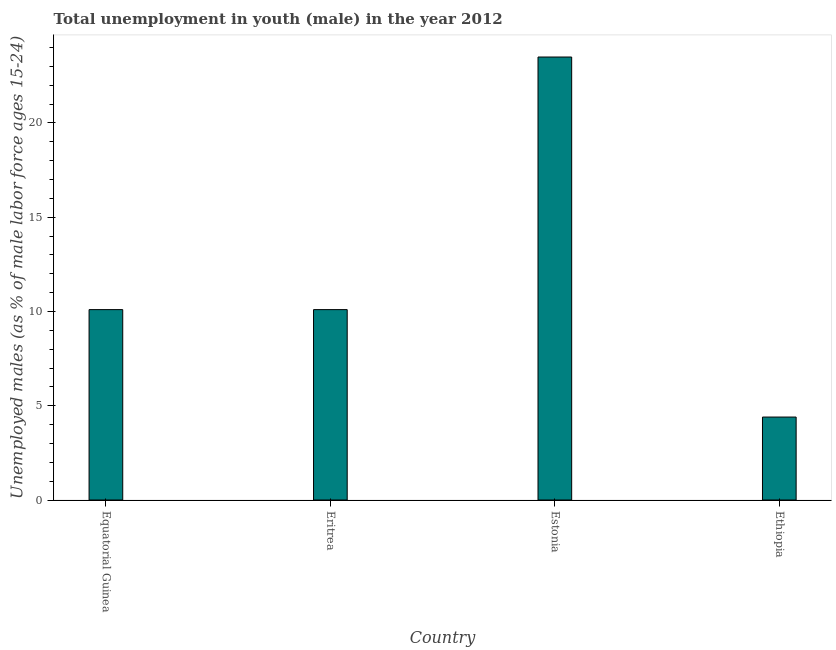Does the graph contain any zero values?
Give a very brief answer. No. Does the graph contain grids?
Offer a terse response. No. What is the title of the graph?
Offer a terse response. Total unemployment in youth (male) in the year 2012. What is the label or title of the Y-axis?
Ensure brevity in your answer.  Unemployed males (as % of male labor force ages 15-24). What is the unemployed male youth population in Equatorial Guinea?
Provide a succinct answer. 10.1. Across all countries, what is the minimum unemployed male youth population?
Make the answer very short. 4.4. In which country was the unemployed male youth population maximum?
Provide a short and direct response. Estonia. In which country was the unemployed male youth population minimum?
Offer a terse response. Ethiopia. What is the sum of the unemployed male youth population?
Your answer should be very brief. 48.1. What is the average unemployed male youth population per country?
Provide a short and direct response. 12.03. What is the median unemployed male youth population?
Offer a terse response. 10.1. What is the ratio of the unemployed male youth population in Eritrea to that in Ethiopia?
Your answer should be very brief. 2.29. Is the unemployed male youth population in Equatorial Guinea less than that in Eritrea?
Offer a very short reply. No. Is the sum of the unemployed male youth population in Equatorial Guinea and Ethiopia greater than the maximum unemployed male youth population across all countries?
Your answer should be compact. No. What is the difference between the highest and the lowest unemployed male youth population?
Your response must be concise. 19.1. Are all the bars in the graph horizontal?
Provide a short and direct response. No. What is the difference between two consecutive major ticks on the Y-axis?
Offer a terse response. 5. Are the values on the major ticks of Y-axis written in scientific E-notation?
Provide a succinct answer. No. What is the Unemployed males (as % of male labor force ages 15-24) of Equatorial Guinea?
Your response must be concise. 10.1. What is the Unemployed males (as % of male labor force ages 15-24) in Eritrea?
Ensure brevity in your answer.  10.1. What is the Unemployed males (as % of male labor force ages 15-24) in Estonia?
Offer a very short reply. 23.5. What is the Unemployed males (as % of male labor force ages 15-24) in Ethiopia?
Make the answer very short. 4.4. What is the difference between the Unemployed males (as % of male labor force ages 15-24) in Equatorial Guinea and Estonia?
Provide a succinct answer. -13.4. What is the difference between the Unemployed males (as % of male labor force ages 15-24) in Equatorial Guinea and Ethiopia?
Your response must be concise. 5.7. What is the difference between the Unemployed males (as % of male labor force ages 15-24) in Eritrea and Estonia?
Keep it short and to the point. -13.4. What is the difference between the Unemployed males (as % of male labor force ages 15-24) in Eritrea and Ethiopia?
Ensure brevity in your answer.  5.7. What is the difference between the Unemployed males (as % of male labor force ages 15-24) in Estonia and Ethiopia?
Provide a succinct answer. 19.1. What is the ratio of the Unemployed males (as % of male labor force ages 15-24) in Equatorial Guinea to that in Eritrea?
Make the answer very short. 1. What is the ratio of the Unemployed males (as % of male labor force ages 15-24) in Equatorial Guinea to that in Estonia?
Your answer should be compact. 0.43. What is the ratio of the Unemployed males (as % of male labor force ages 15-24) in Equatorial Guinea to that in Ethiopia?
Your answer should be compact. 2.29. What is the ratio of the Unemployed males (as % of male labor force ages 15-24) in Eritrea to that in Estonia?
Keep it short and to the point. 0.43. What is the ratio of the Unemployed males (as % of male labor force ages 15-24) in Eritrea to that in Ethiopia?
Make the answer very short. 2.29. What is the ratio of the Unemployed males (as % of male labor force ages 15-24) in Estonia to that in Ethiopia?
Ensure brevity in your answer.  5.34. 